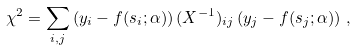<formula> <loc_0><loc_0><loc_500><loc_500>\chi ^ { 2 } = \sum _ { i , j } \left ( y _ { i } - f ( s _ { i } ; \alpha ) \right ) ( X ^ { - 1 } ) _ { i j } \left ( y _ { j } - f ( s _ { j } ; \alpha ) \right ) \, ,</formula> 